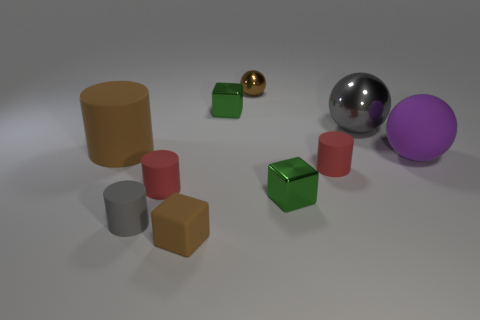Subtract all large purple matte spheres. How many spheres are left? 2 Subtract 2 cylinders. How many cylinders are left? 2 Subtract all brown cubes. How many cubes are left? 2 Subtract all blocks. How many objects are left? 7 Subtract all purple cylinders. How many brown blocks are left? 1 Subtract all blue metal spheres. Subtract all big rubber cylinders. How many objects are left? 9 Add 4 small brown spheres. How many small brown spheres are left? 5 Add 4 brown balls. How many brown balls exist? 5 Subtract 1 brown cylinders. How many objects are left? 9 Subtract all yellow blocks. Subtract all cyan spheres. How many blocks are left? 3 